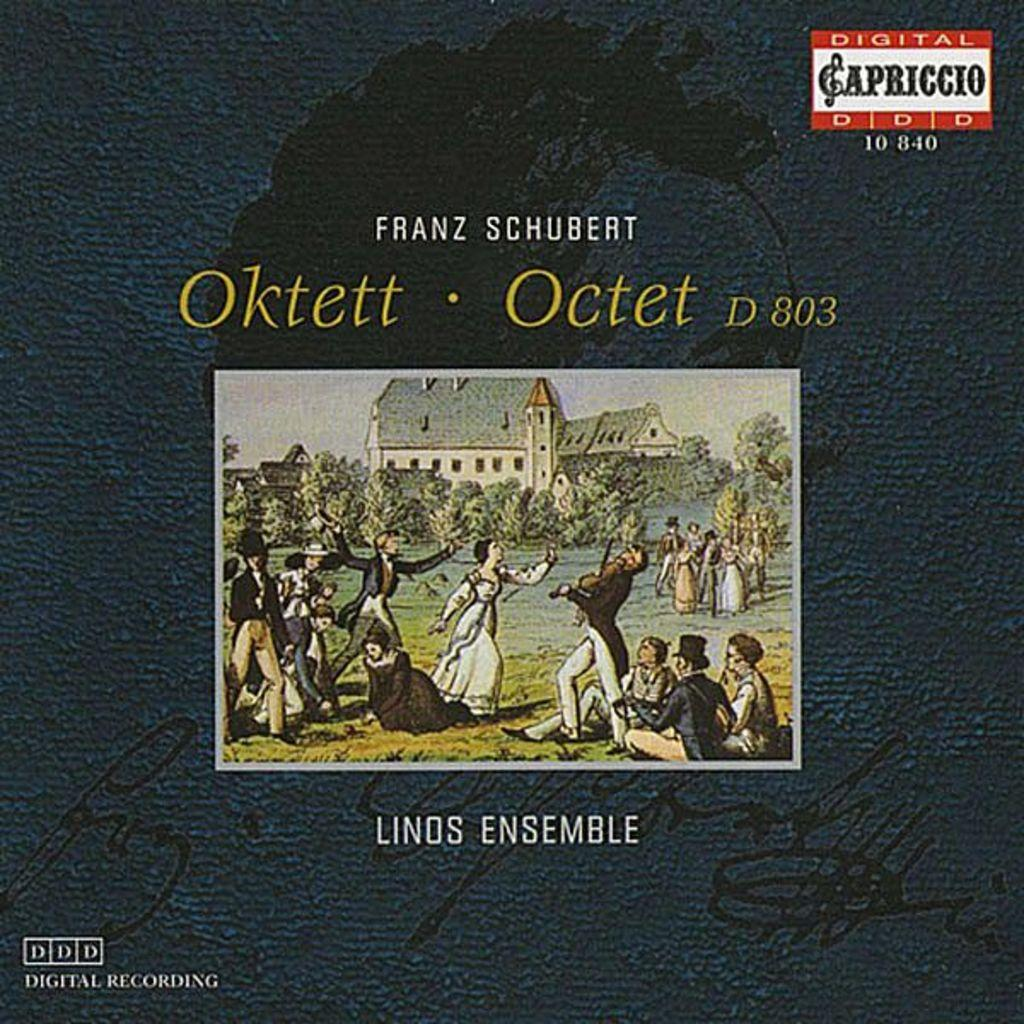Provide a one-sentence caption for the provided image. An old time painting is used to advertise Frank Schubert Linds Ensemble. 